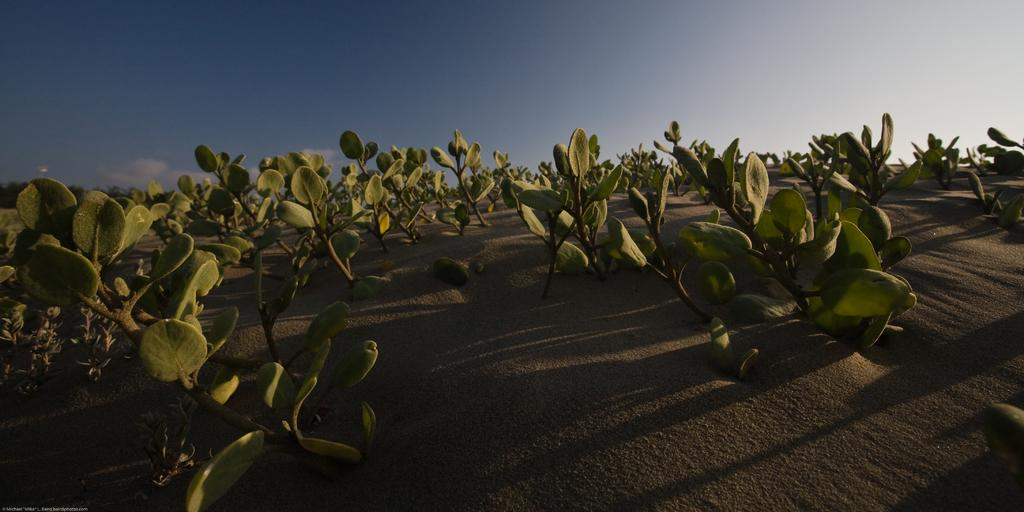What type of living organisms can be seen in the image? Plants can be seen in the image. Where are the plants located? The plants are in a farm. What is visible at the top of the image? The sky is visible at the top of the image. Can you determine the time of day the image was taken? The image may have been taken during the evening, based on the available information. What type of bird can be seen perched on the calendar in the image? There is no bird or calendar present in the image; it features plants in a farm with a visible sky. 